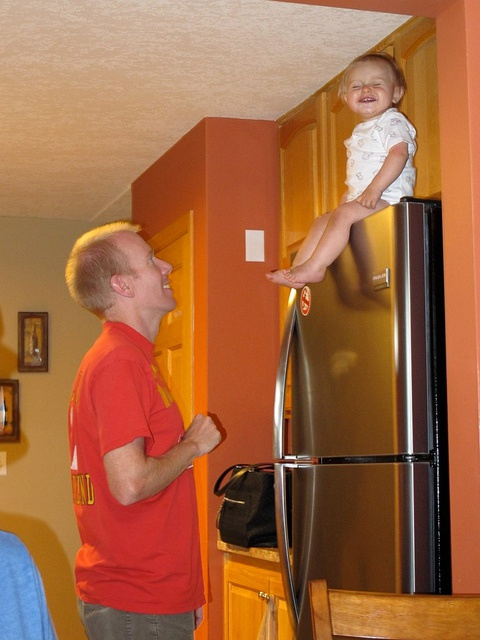Describe the objects in this image and their specific colors. I can see refrigerator in tan, maroon, black, and olive tones, people in tan, brown, and red tones, people in tan, lightgray, and salmon tones, chair in tan, red, and orange tones, and handbag in tan, black, maroon, and brown tones in this image. 